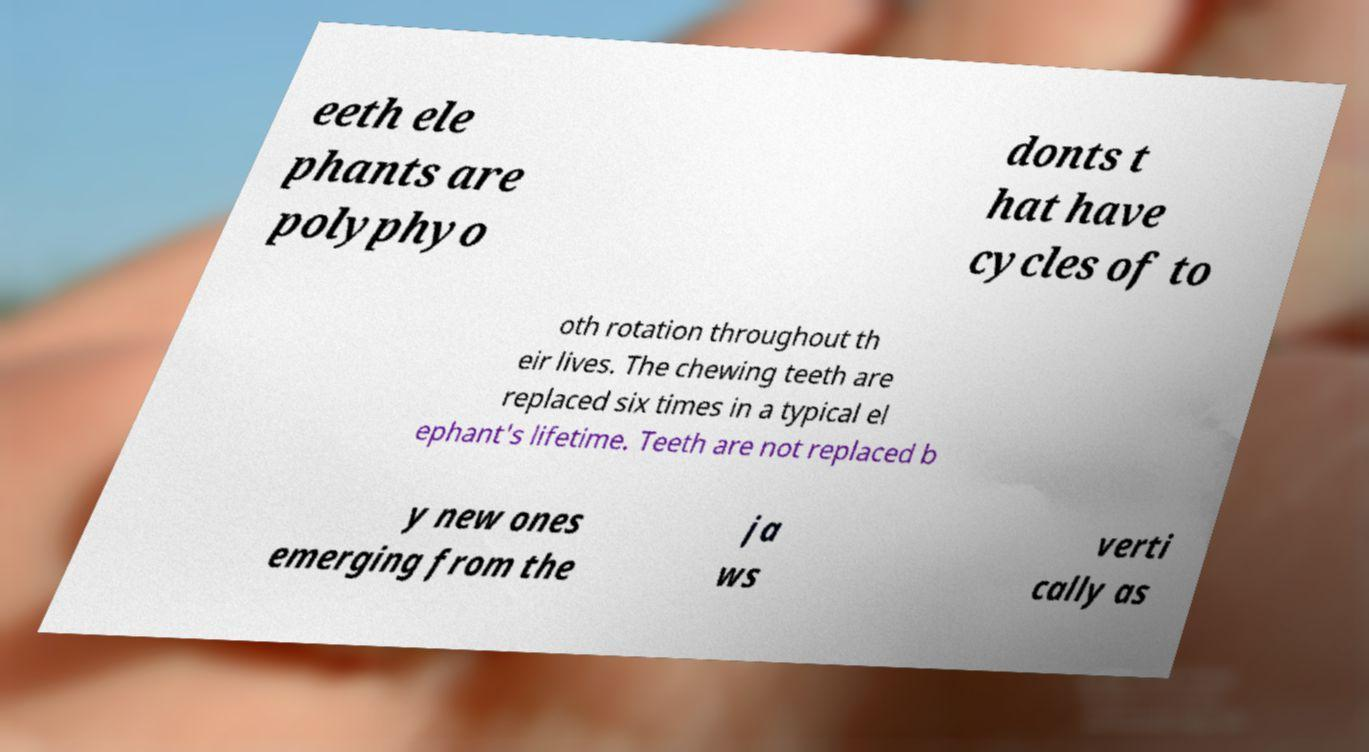Please identify and transcribe the text found in this image. eeth ele phants are polyphyo donts t hat have cycles of to oth rotation throughout th eir lives. The chewing teeth are replaced six times in a typical el ephant's lifetime. Teeth are not replaced b y new ones emerging from the ja ws verti cally as 